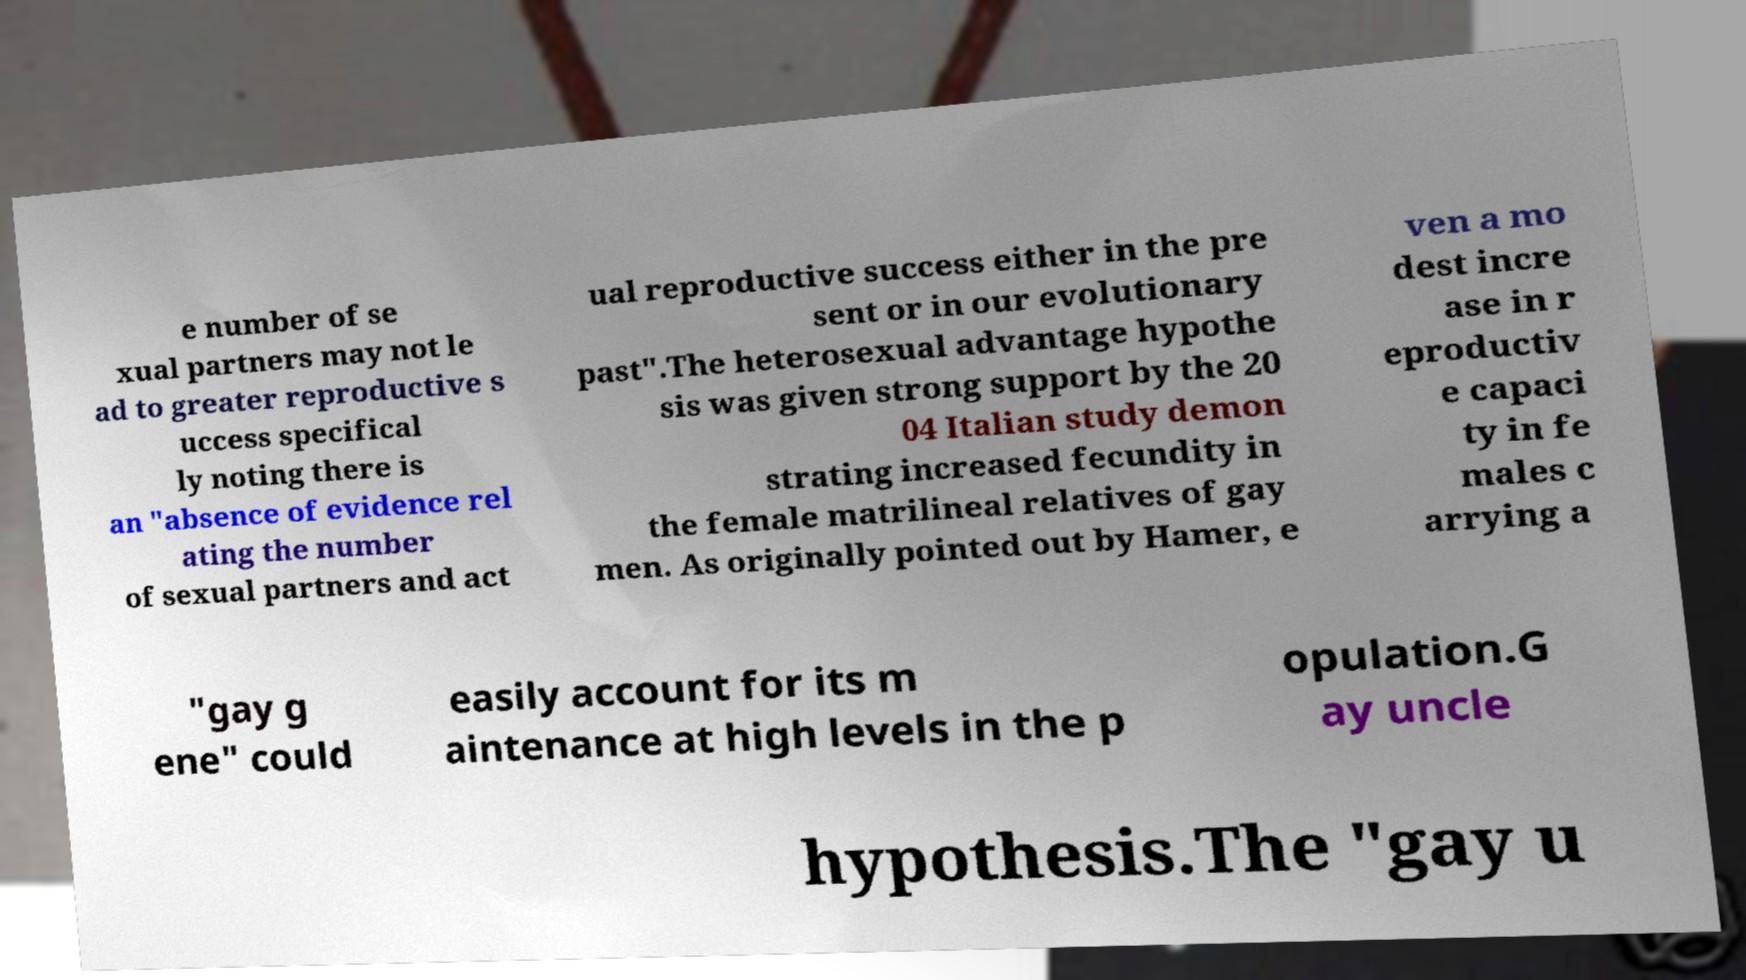Can you read and provide the text displayed in the image?This photo seems to have some interesting text. Can you extract and type it out for me? e number of se xual partners may not le ad to greater reproductive s uccess specifical ly noting there is an "absence of evidence rel ating the number of sexual partners and act ual reproductive success either in the pre sent or in our evolutionary past".The heterosexual advantage hypothe sis was given strong support by the 20 04 Italian study demon strating increased fecundity in the female matrilineal relatives of gay men. As originally pointed out by Hamer, e ven a mo dest incre ase in r eproductiv e capaci ty in fe males c arrying a "gay g ene" could easily account for its m aintenance at high levels in the p opulation.G ay uncle hypothesis.The "gay u 